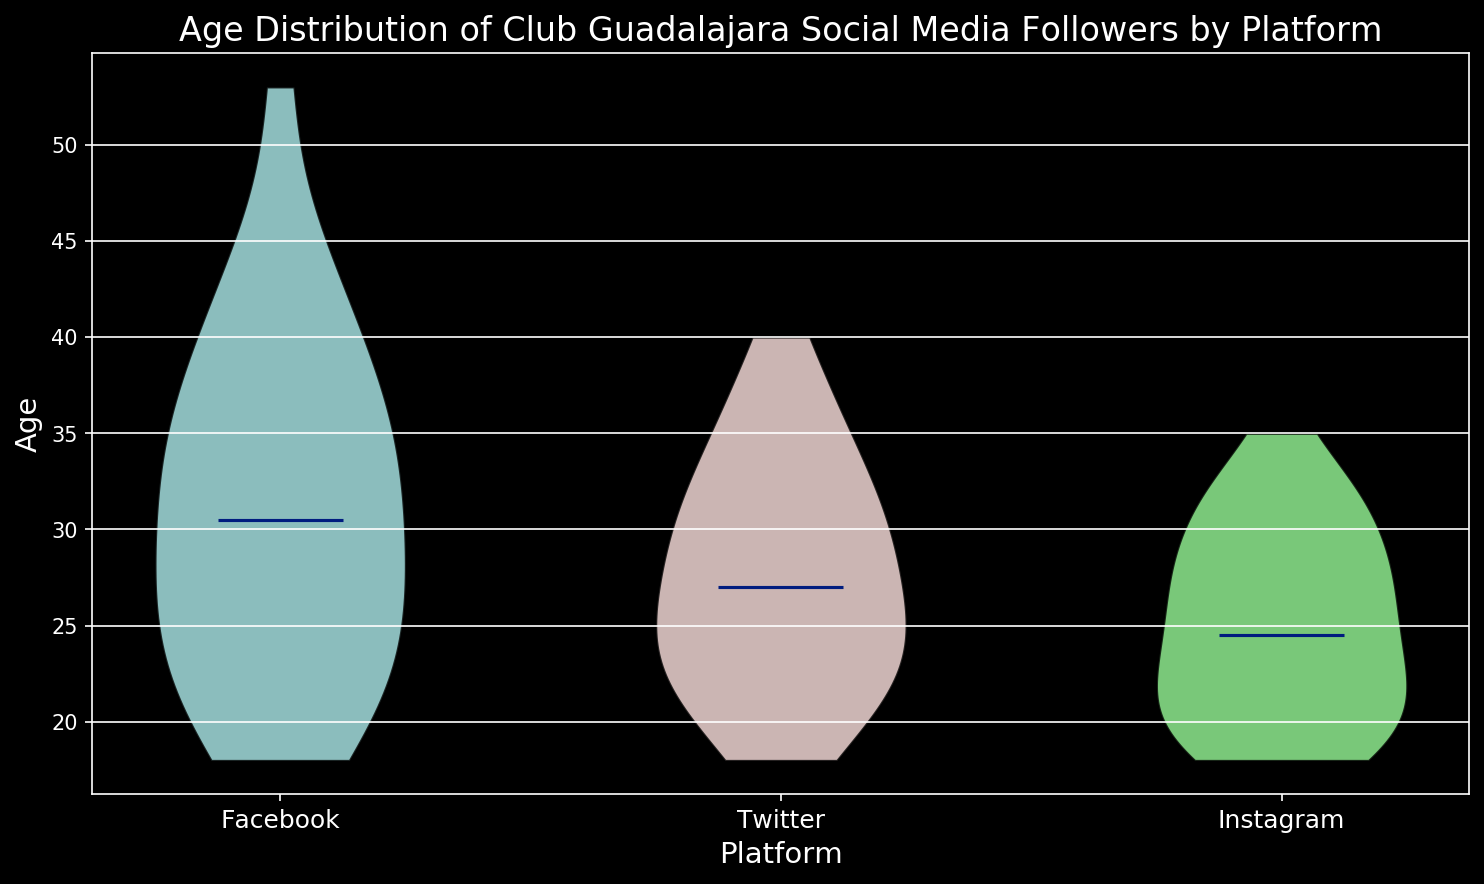what platform has the youngest median age of followers? To determine the platform with the youngest median age, look at the location of the median (the horizontal line inside the violin) for each platform and see which one is lowest.
Answer: Instagram Which platform has the widest spread of ages among followers? The spread of ages can be determined by the height of the violins. The taller the violin, the wider the spread. Look at the overall height of each violin plot.
Answer: Facebook What is the median age of Instagram followers? The median age is indicated by the central horizontal line inside the violin plot for Instagram. Look at this line and refer to the y-axis to read off the median age.
Answer: 24 Is the median age of Twitter followers higher or lower than that of Facebook followers? Compare the positions of the median lines for Twitter and Facebook; the one that is higher on the y-axis represents a higher median age.
Answer: Lower Compare the spread of ages among Facebook and Twitter followers. Which has a larger range? To compare the range, look at the overall height of the violins for both Facebook and Twitter. The taller the violin, the larger the range.
Answer: Facebook What can you infer about the central age distribution of Instagram followers based on the shape of the violin plot? The shape of the violin plot indicates the density of ages. A wider middle section implies that most followers' ages are around the median value.
Answer: Wide around median Which platform appears to have the most uniform distribution of follower ages? Look for the violin plot that has the most even width from top to bottom, indicating a more uniform distribution.
Answer: Twitter What is the approximate age range of Facebook followers? Assess the upper and lower extents of the Facebook violin plot and match these to the y-axis to determine the age range.
Answer: 18 to 53 Between Instagram and Twitter, which has followers with a higher maximum age? Look at the top of the violin plots for Instagram and Twitter and compare which plot extends higher on the y-axis.
Answer: Twitter 